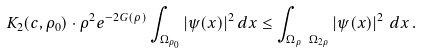Convert formula to latex. <formula><loc_0><loc_0><loc_500><loc_500>K _ { 2 } ( c , \rho _ { 0 } ) \cdot \rho ^ { 2 } e ^ { - 2 G ( \rho ) } \int _ { \Omega _ { \rho _ { 0 } } } | \psi ( x ) | ^ { 2 } \, d x \leq \int _ { \Omega _ { \rho } \ \Omega _ { 2 \rho } } \left | \psi ( x ) \right | ^ { 2 } \, d x \, .</formula> 